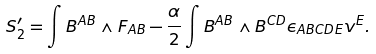<formula> <loc_0><loc_0><loc_500><loc_500>S ^ { \prime } _ { 2 } = \int B ^ { A B } \wedge F _ { A B } - \frac { \alpha } { 2 } \int B ^ { A B } \wedge B ^ { C D } \epsilon _ { A B C D E } v ^ { E } .</formula> 